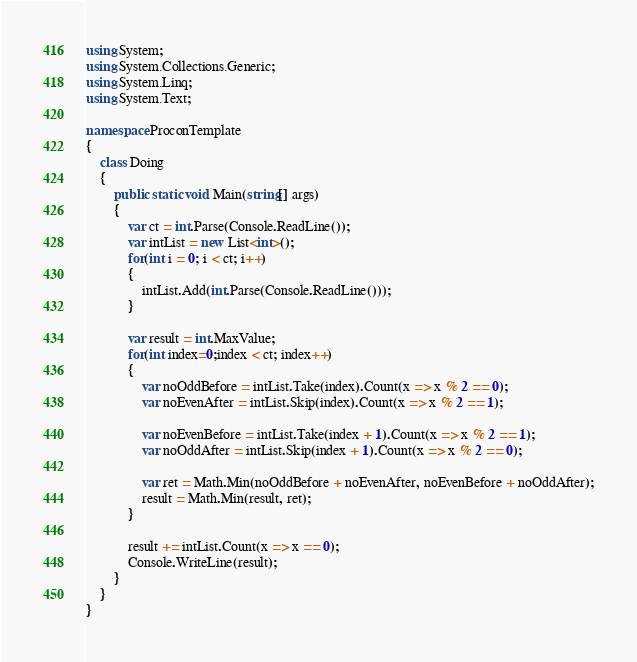<code> <loc_0><loc_0><loc_500><loc_500><_C#_>using System;
using System.Collections.Generic;
using System.Linq;
using System.Text;

namespace ProconTemplate
{
    class Doing
    {
        public static void Main(string[] args)
        {
            var ct = int.Parse(Console.ReadLine());
            var intList = new List<int>();
            for(int i = 0; i < ct; i++)
            {
                intList.Add(int.Parse(Console.ReadLine()));
            }

            var result = int.MaxValue;
            for(int index=0;index < ct; index++)
            {
                var noOddBefore = intList.Take(index).Count(x => x % 2 == 0);
                var noEvenAfter = intList.Skip(index).Count(x => x % 2 == 1);

                var noEvenBefore = intList.Take(index + 1).Count(x => x % 2 == 1);
                var noOddAfter = intList.Skip(index + 1).Count(x => x % 2 == 0);

                var ret = Math.Min(noOddBefore + noEvenAfter, noEvenBefore + noOddAfter);
                result = Math.Min(result, ret);
            }

            result += intList.Count(x => x == 0);
            Console.WriteLine(result);
        }
    }
}
</code> 